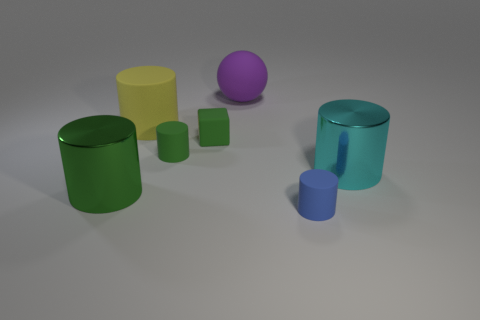What is the blue cylinder made of?
Ensure brevity in your answer.  Rubber. What number of metallic objects are either blue cylinders or small purple things?
Give a very brief answer. 0. Is the number of green rubber objects that are in front of the small blue cylinder less than the number of matte cylinders that are behind the large green cylinder?
Offer a very short reply. Yes. There is a green matte object that is behind the tiny green rubber object that is in front of the green cube; is there a rubber ball on the left side of it?
Offer a very short reply. No. What is the material of the big cylinder that is the same color as the matte block?
Ensure brevity in your answer.  Metal. Is the shape of the big metal object that is on the right side of the yellow matte object the same as the metal thing that is on the left side of the tiny blue cylinder?
Offer a terse response. Yes. What material is the yellow cylinder that is the same size as the purple sphere?
Your answer should be compact. Rubber. Is the tiny object that is in front of the big cyan thing made of the same material as the big object on the right side of the blue object?
Provide a succinct answer. No. The green object that is the same size as the green matte cylinder is what shape?
Make the answer very short. Cube. What number of other things are there of the same color as the small rubber block?
Keep it short and to the point. 2. 